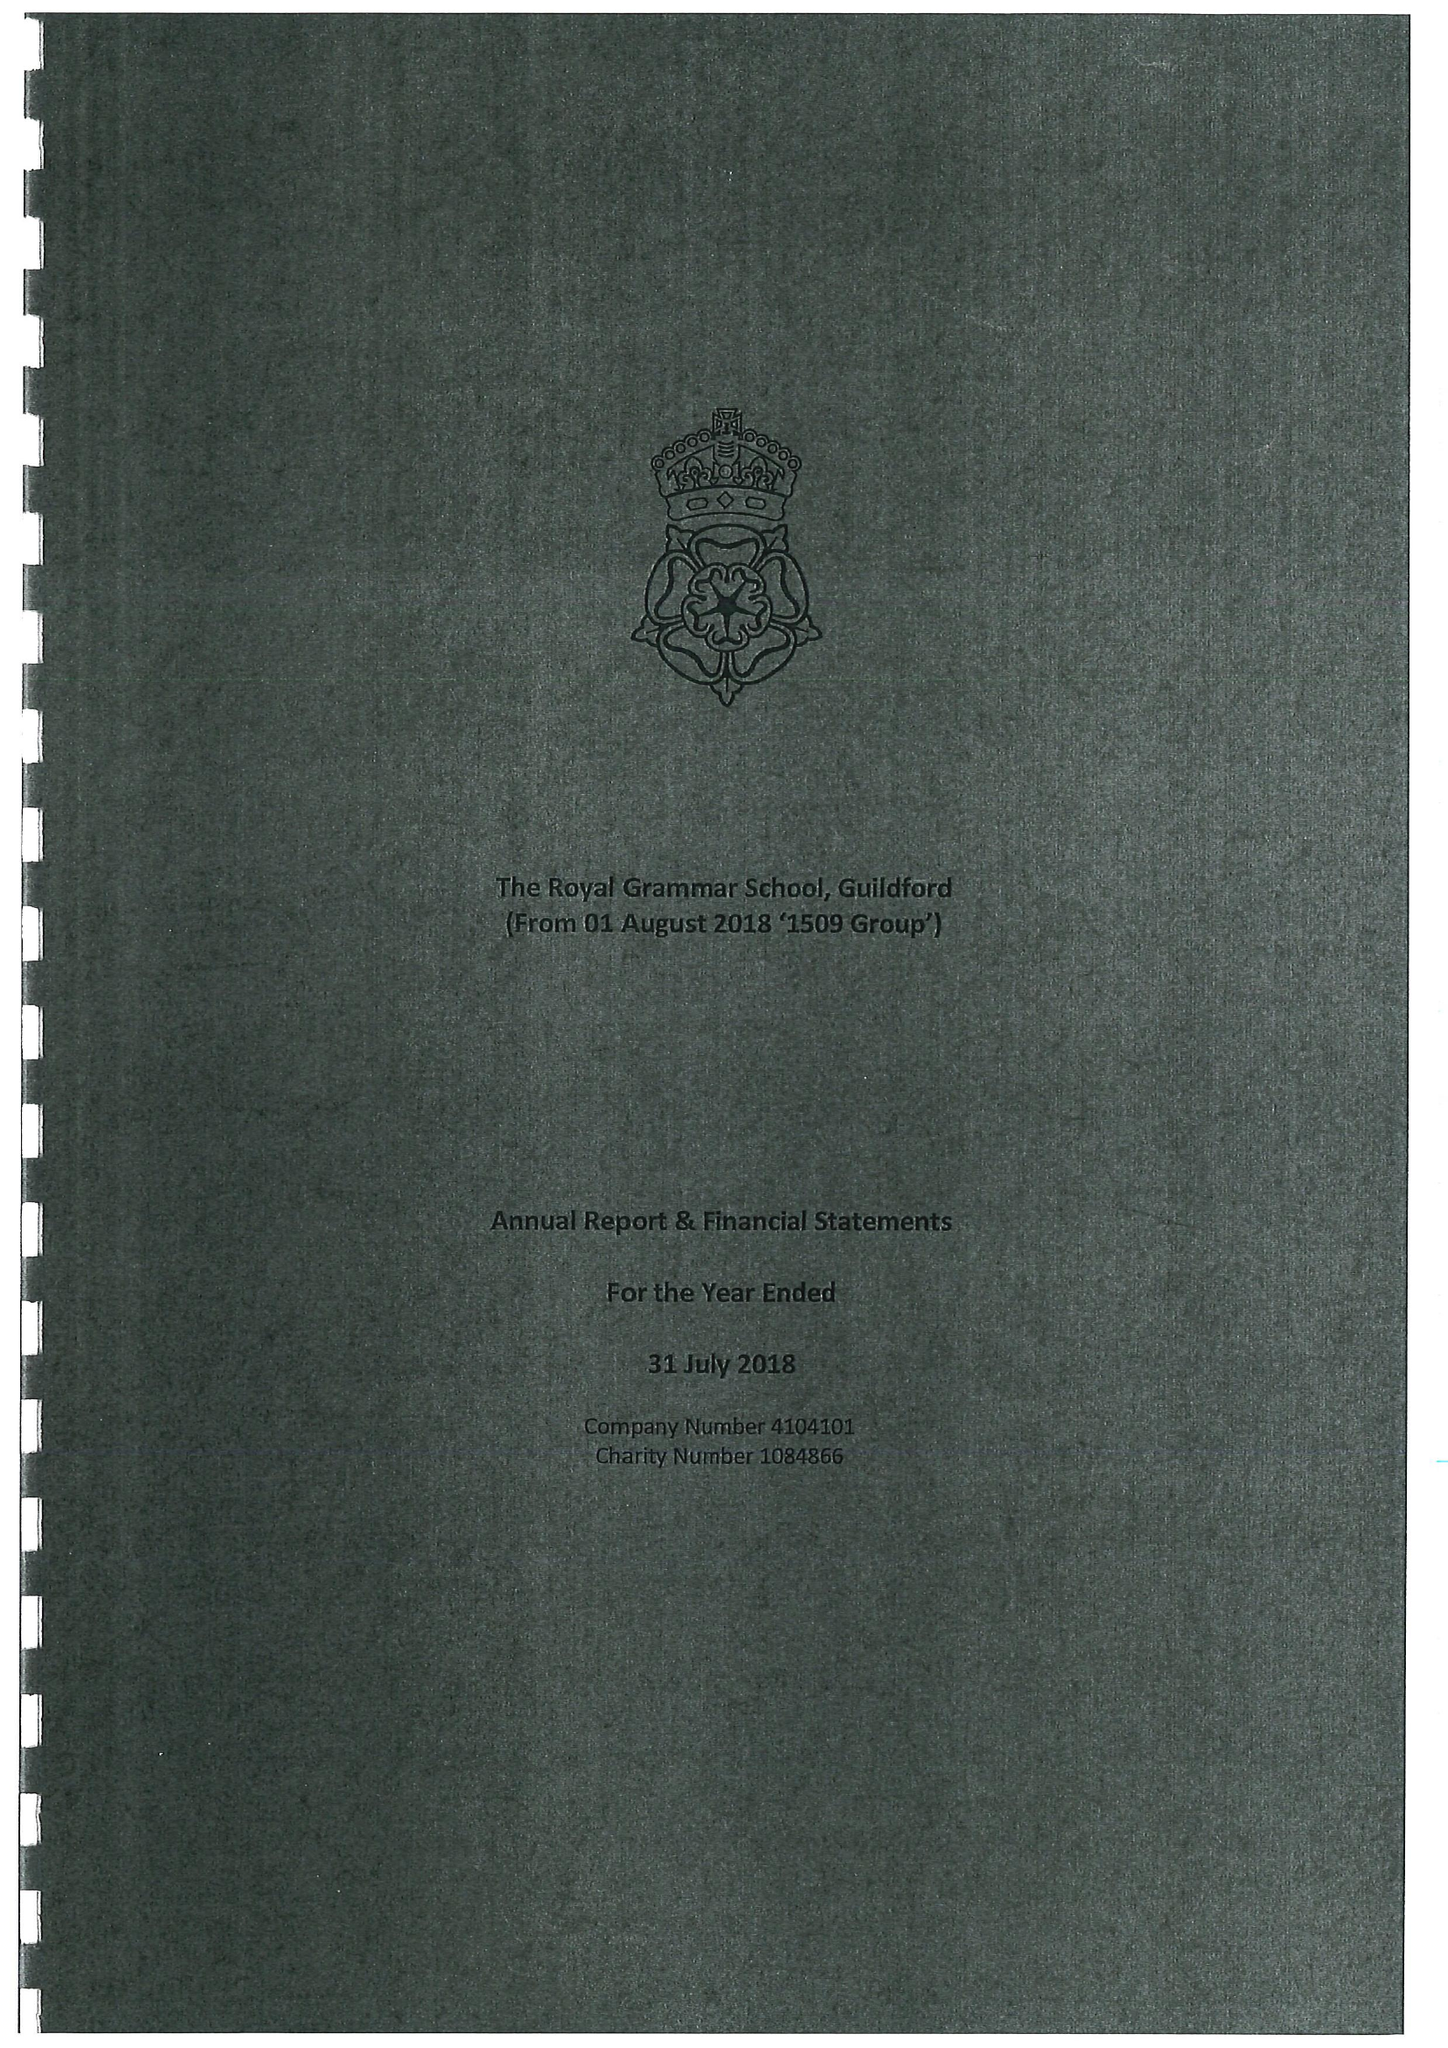What is the value for the charity_number?
Answer the question using a single word or phrase. 1084866 